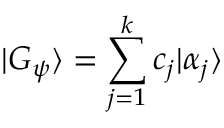Convert formula to latex. <formula><loc_0><loc_0><loc_500><loc_500>| G _ { \psi } \rangle = \sum _ { j = 1 } ^ { k } c _ { j } | \alpha _ { j } \rangle</formula> 